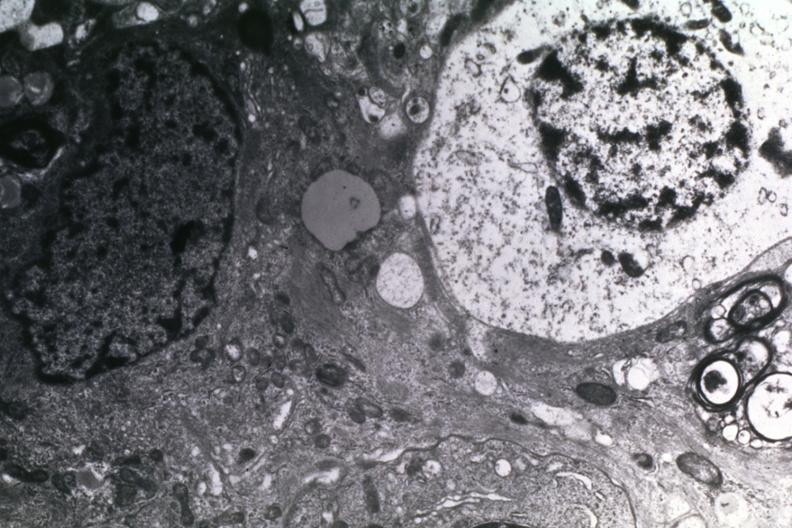what does this image show?
Answer the question using a single word or phrase. Dr garcia tumors 14 